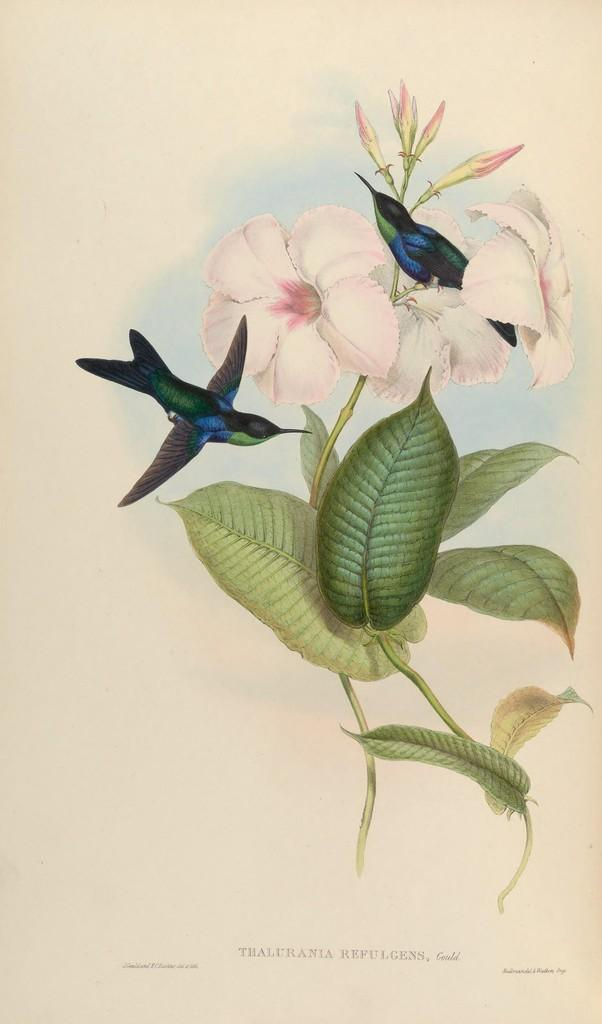What type of artwork is present in the image? The image contains paintings of flowers on stems with leaves. Are there any animals depicted in the image? Yes, there are birds depicted in the image. What can be found at the bottom of the image? There is text written at the bottom of the image. What type of line is used to draw the birds in the image? There is no information about the type of line used to draw the birds in the image. 